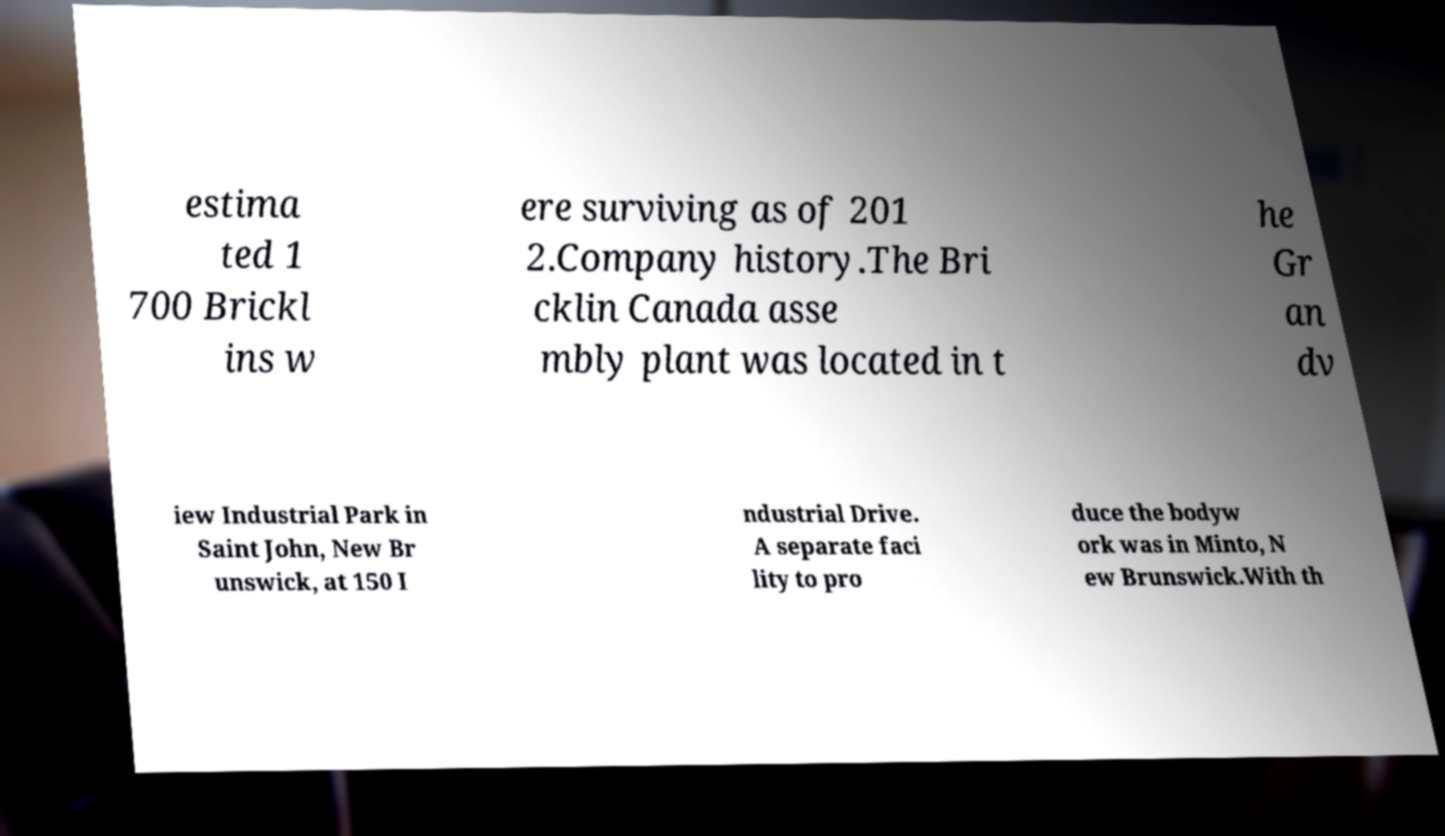Could you assist in decoding the text presented in this image and type it out clearly? estima ted 1 700 Brickl ins w ere surviving as of 201 2.Company history.The Bri cklin Canada asse mbly plant was located in t he Gr an dv iew Industrial Park in Saint John, New Br unswick, at 150 I ndustrial Drive. A separate faci lity to pro duce the bodyw ork was in Minto, N ew Brunswick.With th 